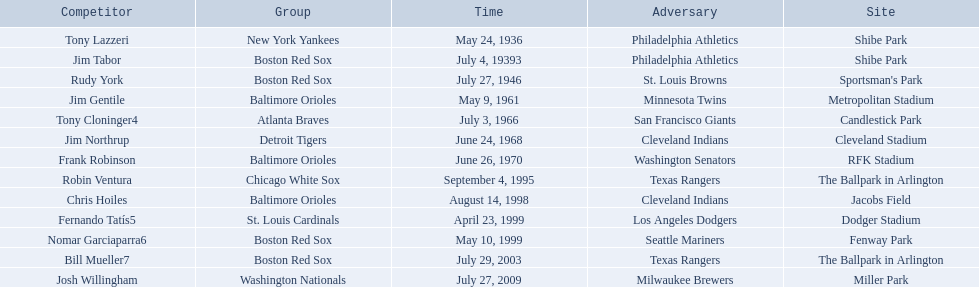What were the dates of each game? May 24, 1936, July 4, 19393, July 27, 1946, May 9, 1961, July 3, 1966, June 24, 1968, June 26, 1970, September 4, 1995, August 14, 1998, April 23, 1999, May 10, 1999, July 29, 2003, July 27, 2009. Who were all of the teams? New York Yankees, Boston Red Sox, Boston Red Sox, Baltimore Orioles, Atlanta Braves, Detroit Tigers, Baltimore Orioles, Chicago White Sox, Baltimore Orioles, St. Louis Cardinals, Boston Red Sox, Boston Red Sox, Washington Nationals. What about their opponents? Philadelphia Athletics, Philadelphia Athletics, St. Louis Browns, Minnesota Twins, San Francisco Giants, Cleveland Indians, Washington Senators, Texas Rangers, Cleveland Indians, Los Angeles Dodgers, Seattle Mariners, Texas Rangers, Milwaukee Brewers. And on which date did the detroit tigers play against the cleveland indians? June 24, 1968. 